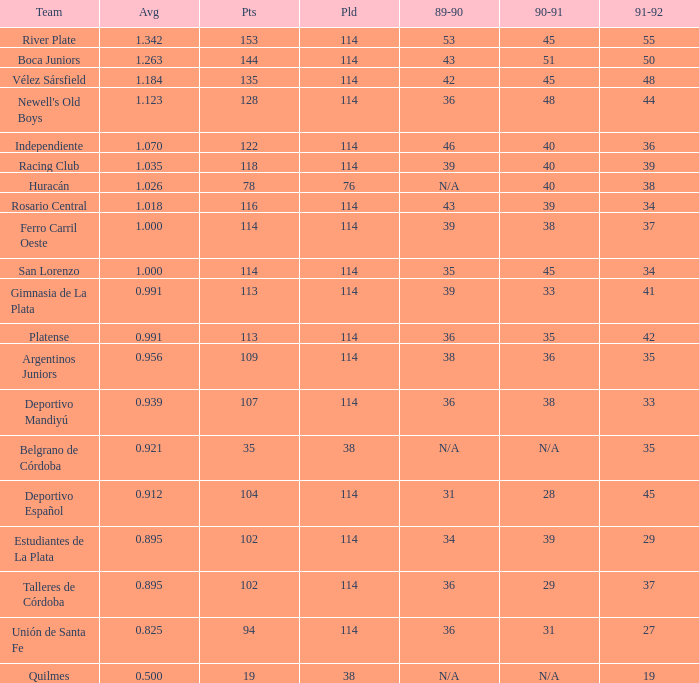How much Played has an Average smaller than 0.9390000000000001, and a 1990-91 of 28? 1.0. 